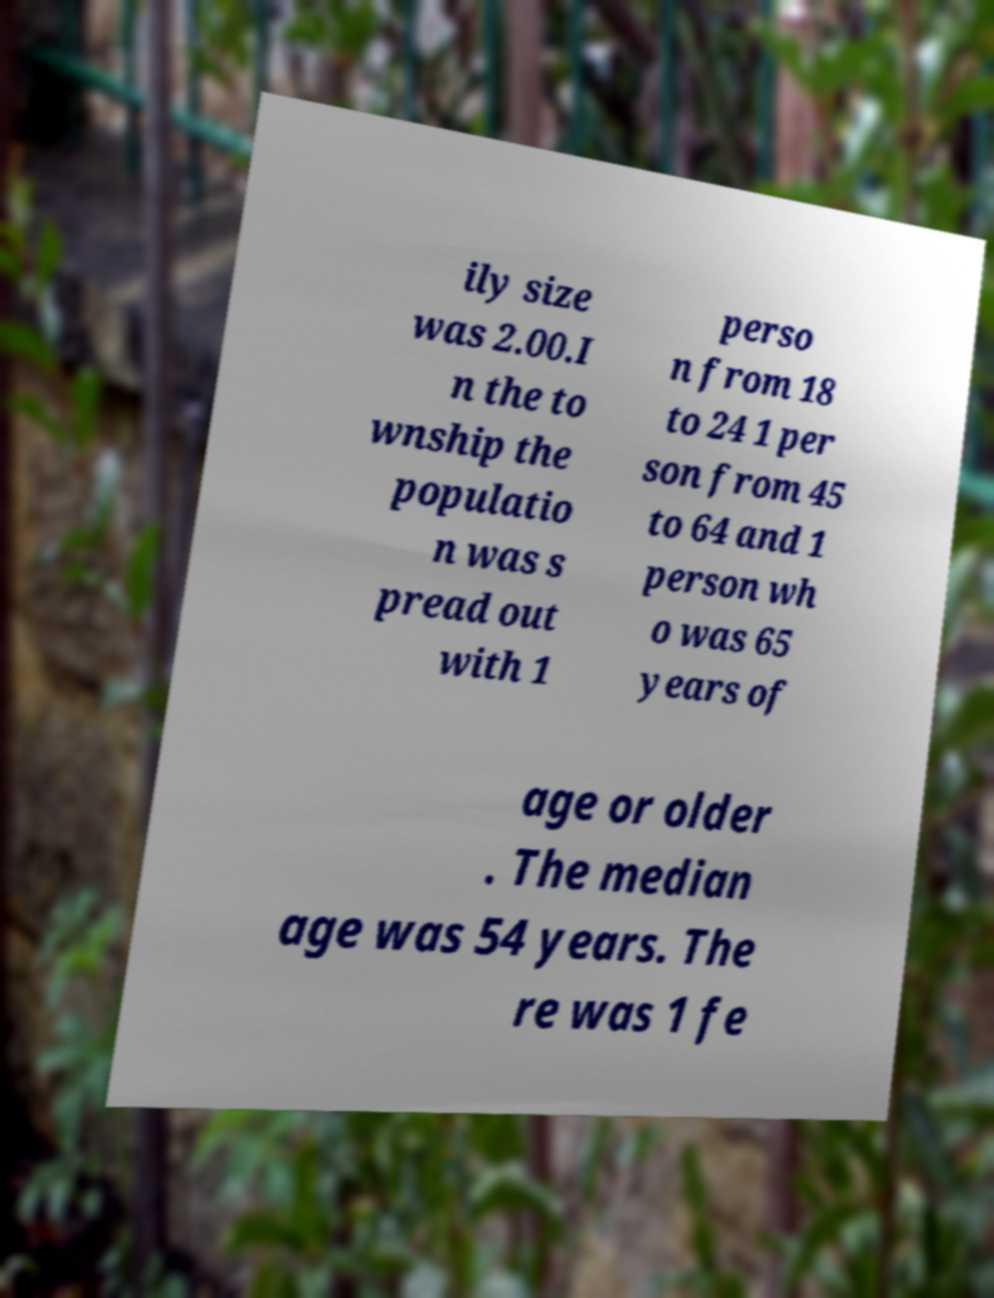For documentation purposes, I need the text within this image transcribed. Could you provide that? ily size was 2.00.I n the to wnship the populatio n was s pread out with 1 perso n from 18 to 24 1 per son from 45 to 64 and 1 person wh o was 65 years of age or older . The median age was 54 years. The re was 1 fe 